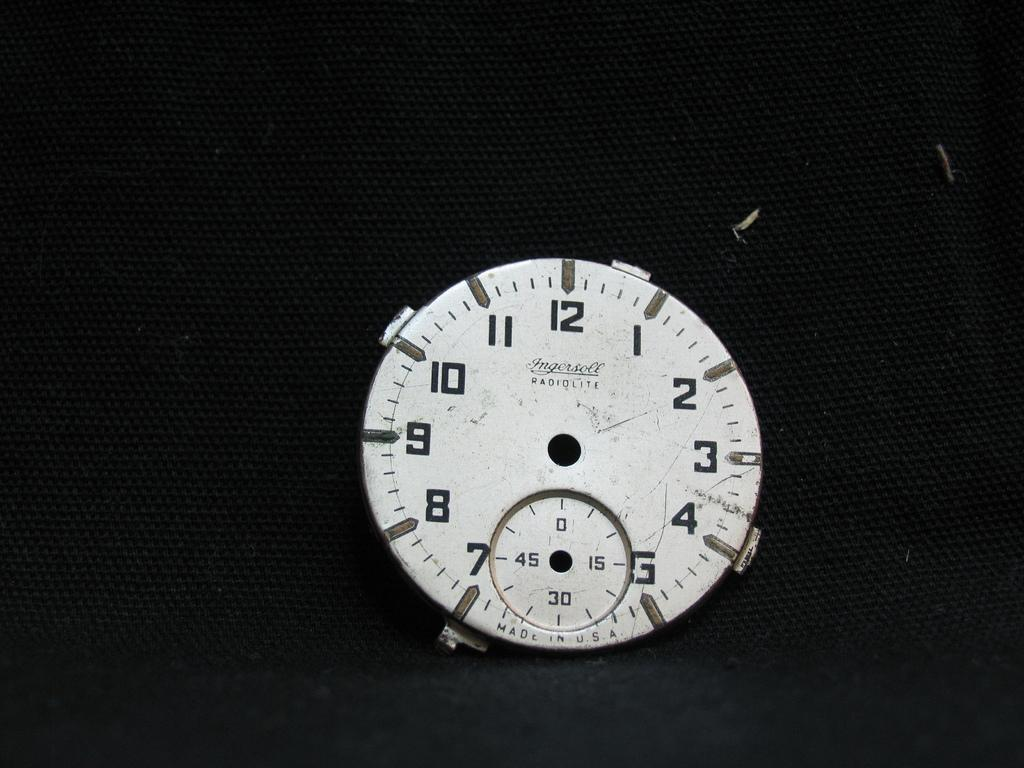<image>
Give a short and clear explanation of the subsequent image. The face of a time piece with Ingersoll RADIOLITE and Made in U.S.A. is shown on a black background. 